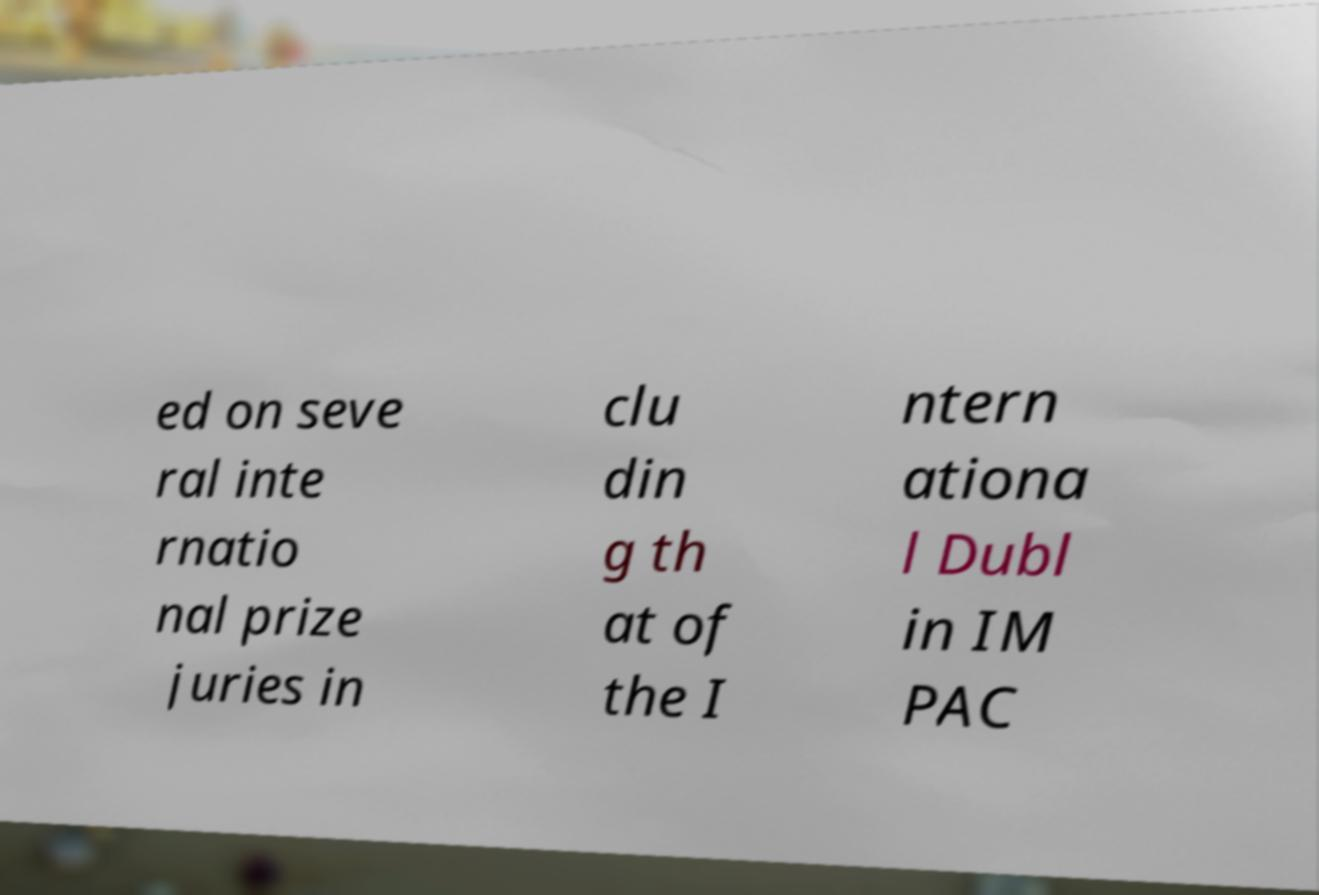There's text embedded in this image that I need extracted. Can you transcribe it verbatim? ed on seve ral inte rnatio nal prize juries in clu din g th at of the I ntern ationa l Dubl in IM PAC 